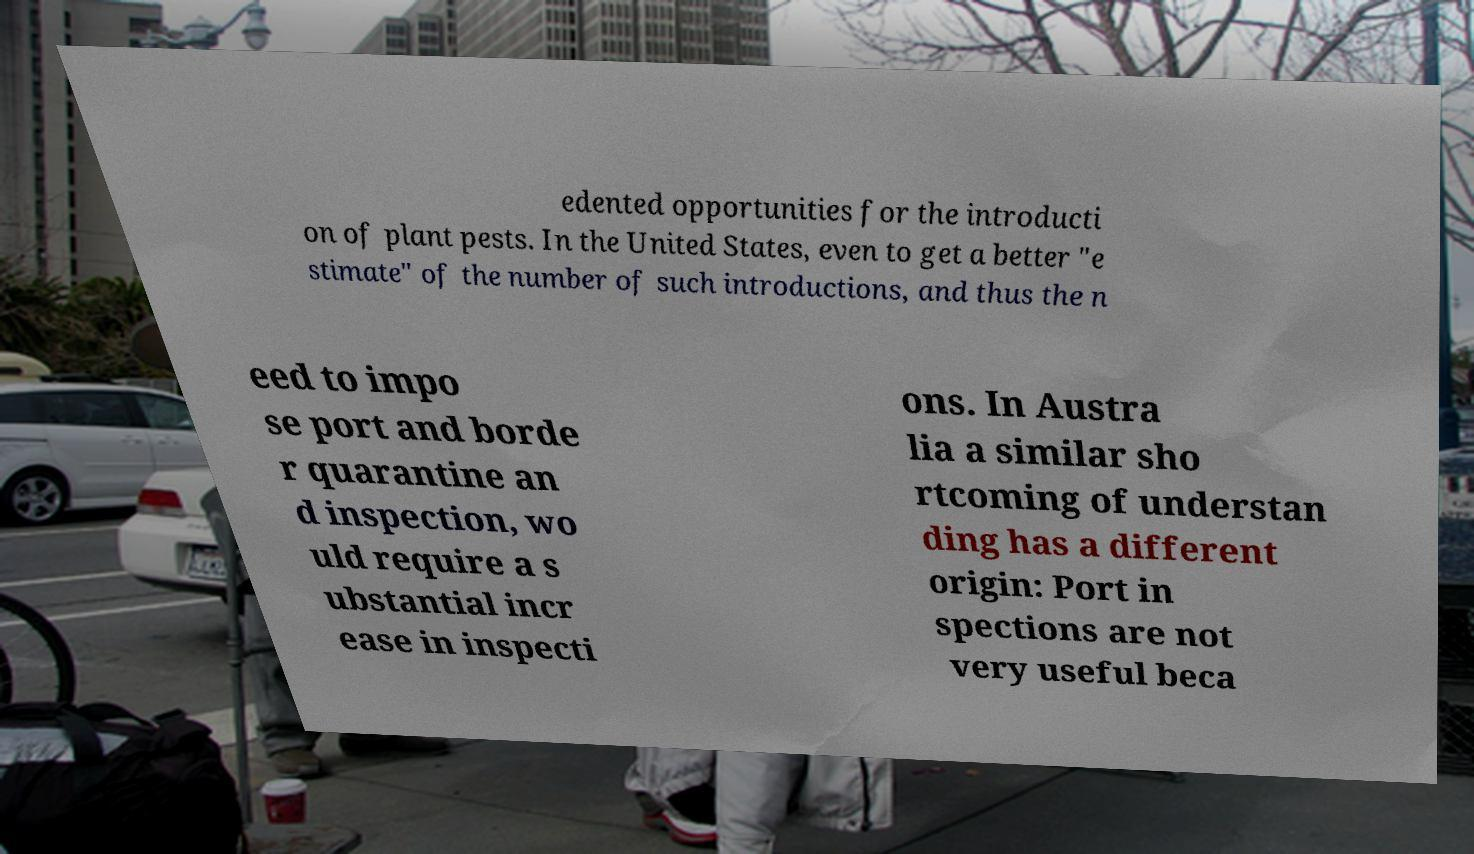Can you read and provide the text displayed in the image?This photo seems to have some interesting text. Can you extract and type it out for me? edented opportunities for the introducti on of plant pests. In the United States, even to get a better "e stimate" of the number of such introductions, and thus the n eed to impo se port and borde r quarantine an d inspection, wo uld require a s ubstantial incr ease in inspecti ons. In Austra lia a similar sho rtcoming of understan ding has a different origin: Port in spections are not very useful beca 